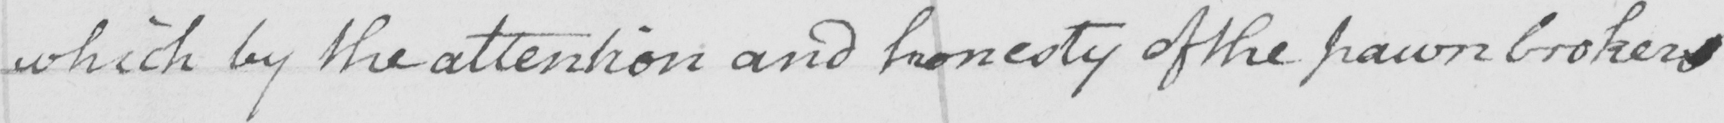Please provide the text content of this handwritten line. which by the attention and honesty of the pawn brokers 